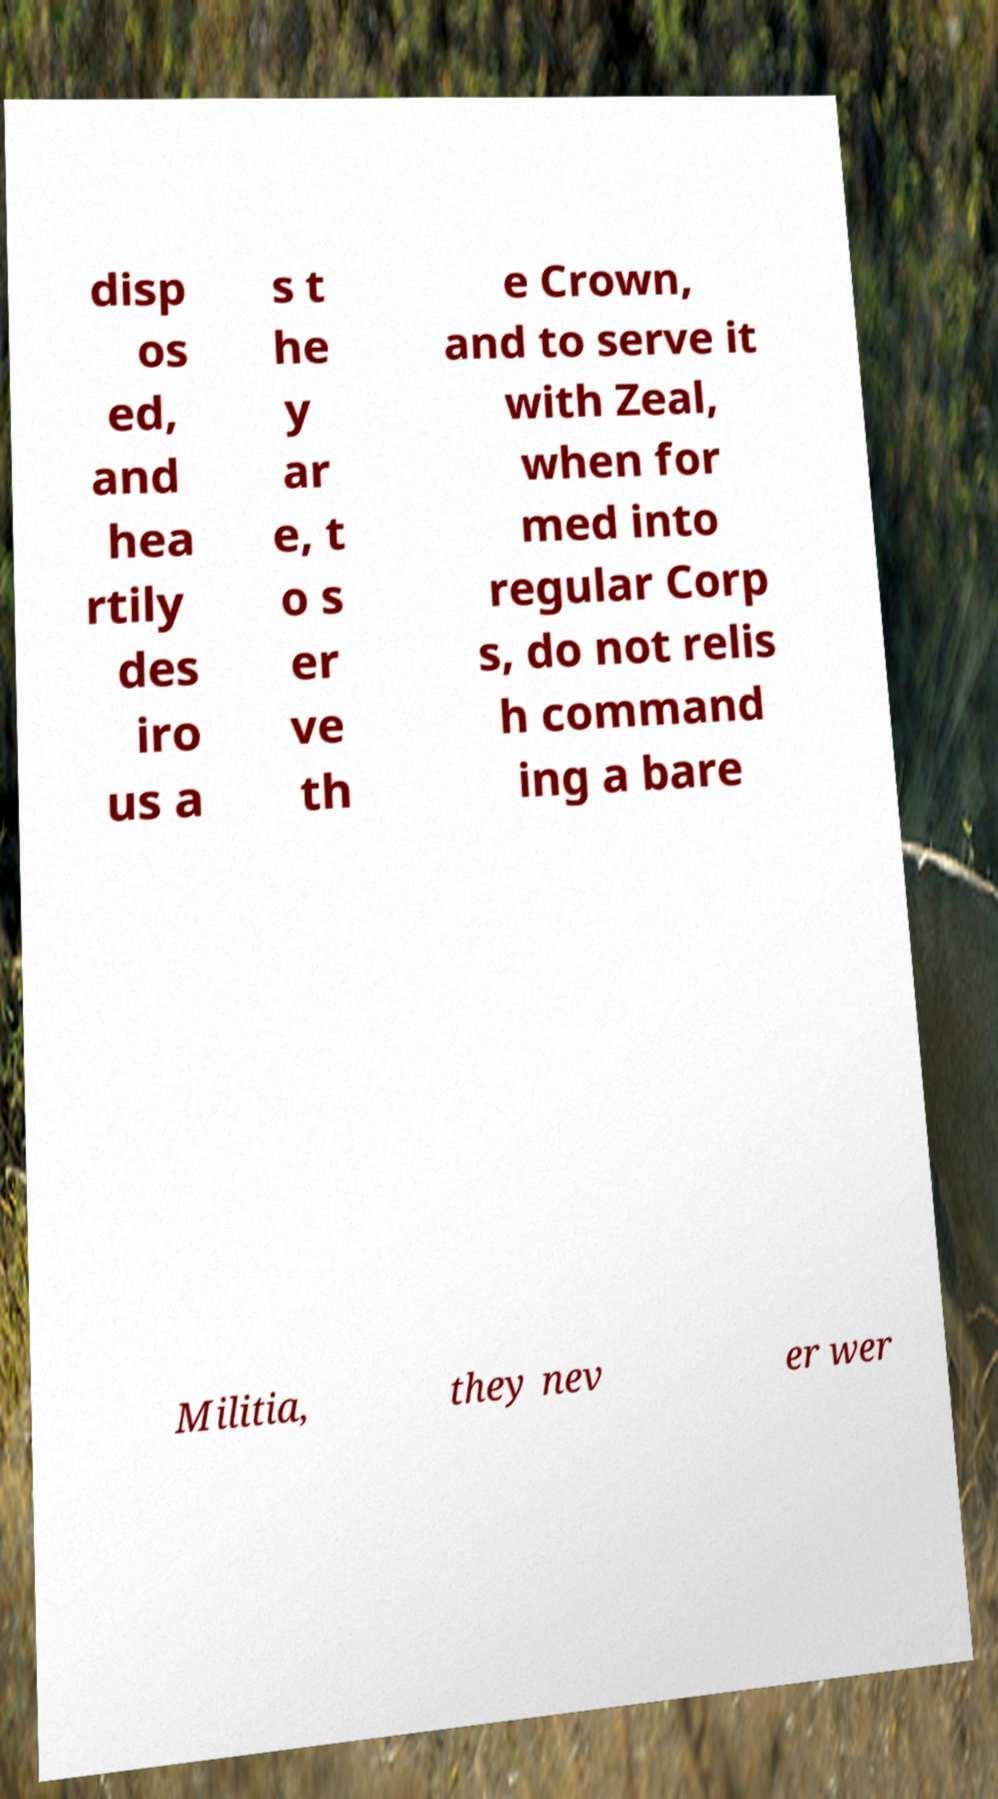Can you read and provide the text displayed in the image?This photo seems to have some interesting text. Can you extract and type it out for me? disp os ed, and hea rtily des iro us a s t he y ar e, t o s er ve th e Crown, and to serve it with Zeal, when for med into regular Corp s, do not relis h command ing a bare Militia, they nev er wer 